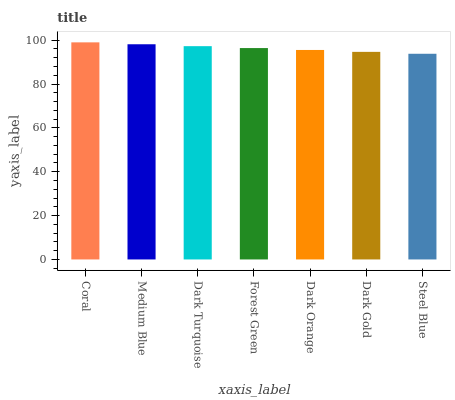Is Medium Blue the minimum?
Answer yes or no. No. Is Medium Blue the maximum?
Answer yes or no. No. Is Coral greater than Medium Blue?
Answer yes or no. Yes. Is Medium Blue less than Coral?
Answer yes or no. Yes. Is Medium Blue greater than Coral?
Answer yes or no. No. Is Coral less than Medium Blue?
Answer yes or no. No. Is Forest Green the high median?
Answer yes or no. Yes. Is Forest Green the low median?
Answer yes or no. Yes. Is Dark Orange the high median?
Answer yes or no. No. Is Dark Gold the low median?
Answer yes or no. No. 